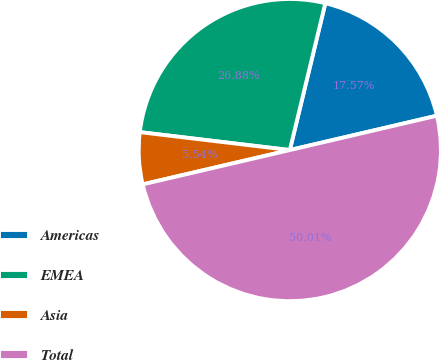Convert chart to OTSL. <chart><loc_0><loc_0><loc_500><loc_500><pie_chart><fcel>Americas<fcel>EMEA<fcel>Asia<fcel>Total<nl><fcel>17.57%<fcel>26.88%<fcel>5.54%<fcel>50.0%<nl></chart> 